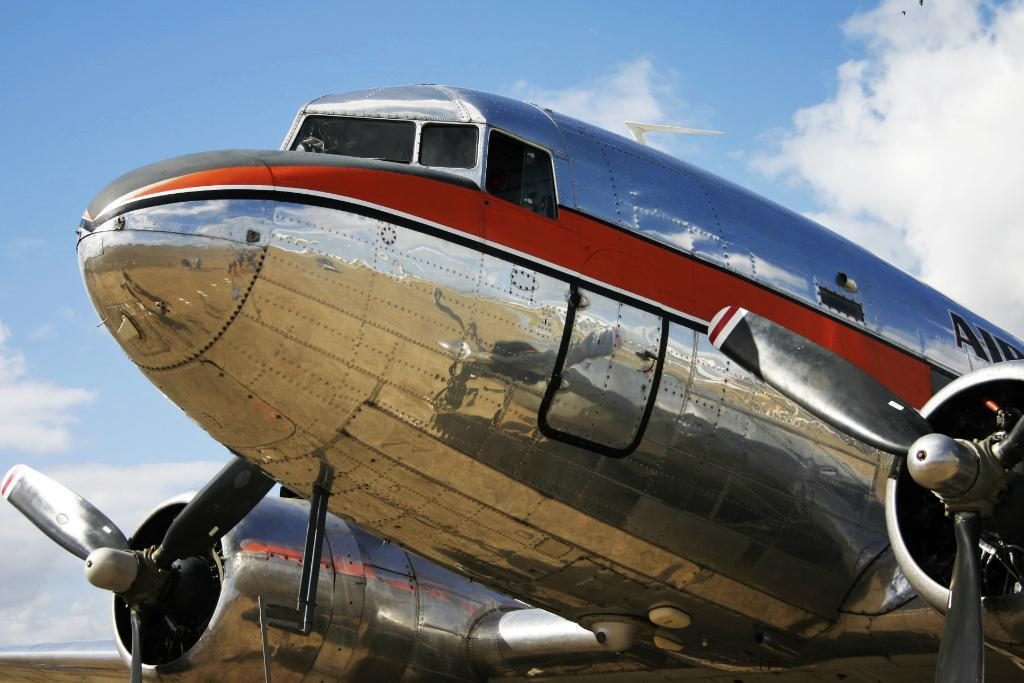What is the main subject of the image? The main subject of the image is an airplane. Are there any words or letters on the airplane? Yes, there is text written on the airplane. What can be seen in the background of the image? The sky in the background is cloudy. Reasoning: Let's think step by step by step in order to produce the conversation. We start by identifying the main subject of the image, which is the airplane. Then, we describe any additional details about the airplane, such as the text written on it. Finally, we mention the background of the image, which is the cloudy sky. Each question is designed to elicit a specific detail about the image that is known from the provided facts. Absurd Question/Answer: What type of oatmeal is being served on the airplane in the image? There is no oatmeal present in the image, as it only features an airplane with text on it and a cloudy sky in the background. 